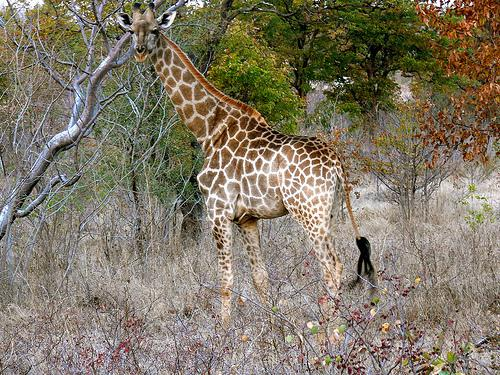Question: what is white and tan?
Choices:
A. The giraffe.
B. Clouds.
C. A man.
D. A sign.
Answer with the letter. Answer: A Question: what is in the picture?
Choices:
A. A man.
B. A giraffe.
C. A woman.
D. An animal.
Answer with the letter. Answer: B Question: what are ossicones?
Choices:
A. Antlers.
B. Horns.
C. Horn like growths.
D. Animal part.
Answer with the letter. Answer: C 